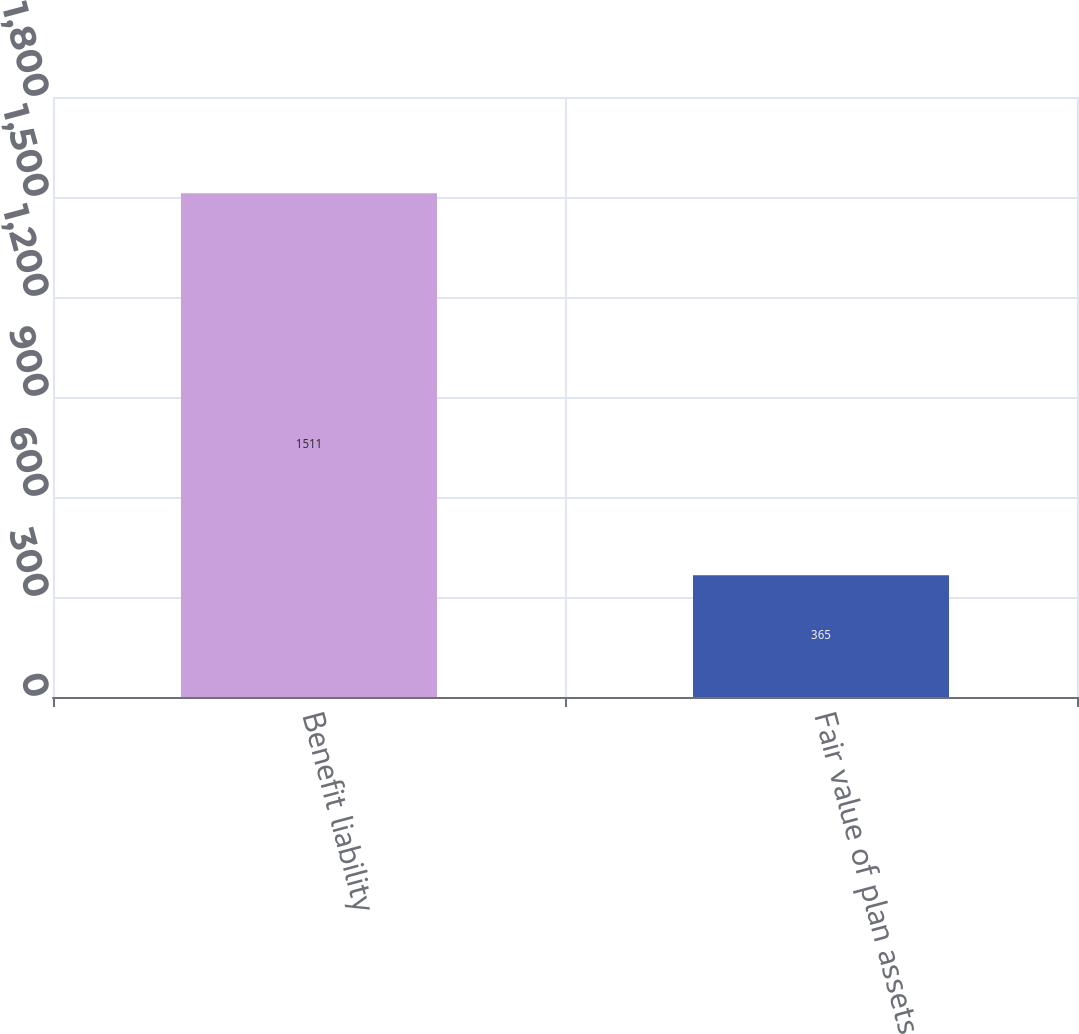<chart> <loc_0><loc_0><loc_500><loc_500><bar_chart><fcel>Benefit liability<fcel>Fair value of plan assets<nl><fcel>1511<fcel>365<nl></chart> 